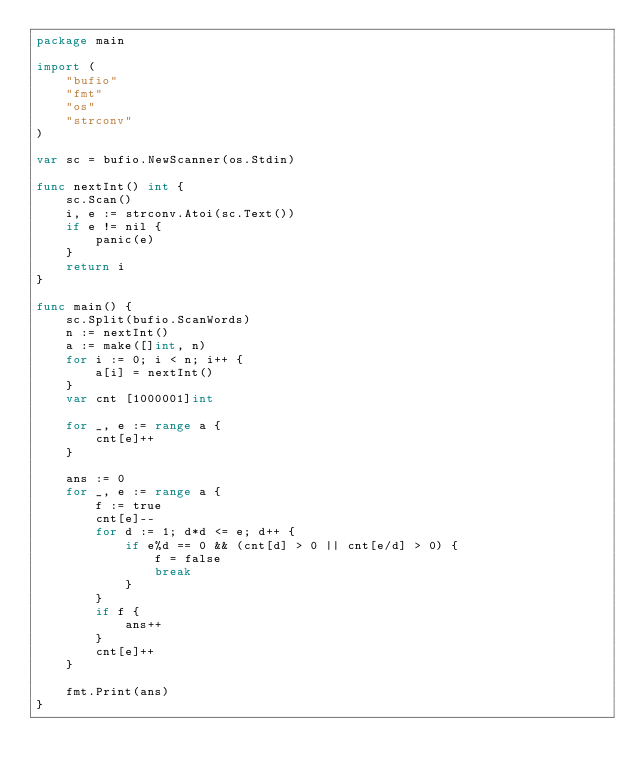<code> <loc_0><loc_0><loc_500><loc_500><_Go_>package main

import (
	"bufio"
	"fmt"
	"os"
	"strconv"
)

var sc = bufio.NewScanner(os.Stdin)

func nextInt() int {
	sc.Scan()
	i, e := strconv.Atoi(sc.Text())
	if e != nil {
		panic(e)
	}
	return i
}

func main() {
	sc.Split(bufio.ScanWords)
	n := nextInt()
	a := make([]int, n)
	for i := 0; i < n; i++ {
		a[i] = nextInt()
	}
	var cnt [1000001]int

	for _, e := range a {
		cnt[e]++
	}

	ans := 0
	for _, e := range a {
		f := true
		cnt[e]--
		for d := 1; d*d <= e; d++ {
			if e%d == 0 && (cnt[d] > 0 || cnt[e/d] > 0) {
				f = false
				break
			}
		}
		if f {
			ans++
		}
		cnt[e]++
	}

	fmt.Print(ans)
}
</code> 